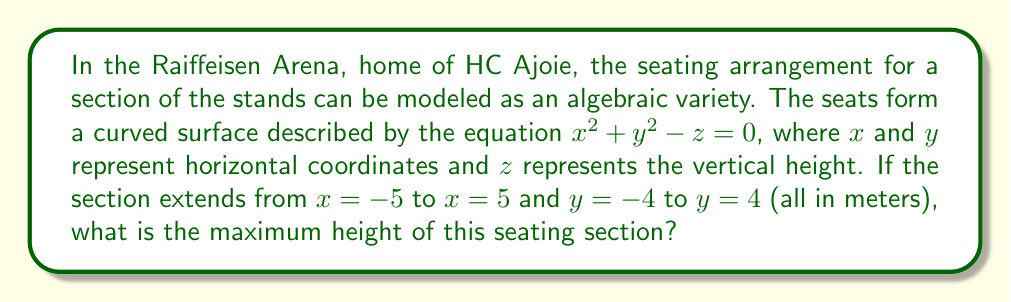Provide a solution to this math problem. Let's approach this step-by-step:

1) The seating arrangement is modeled by the equation $x^2 + y^2 - z = 0$.

2) We need to rearrange this equation to express $z$ in terms of $x$ and $y$:
   $z = x^2 + y^2$

3) The maximum height (z) will occur at the point where $x^2 + y^2$ is largest within the given bounds.

4) The section extends from $x = -5$ to $x = 5$ and $y = -4$ to $y = 4$.

5) The largest possible values for $x^2$ and $y^2$ will be at the corners of this rectangular region:
   $x = \pm 5$ and $y = \pm 4$

6) At these corners:
   $z = x^2 + y^2 = (\pm 5)^2 + (\pm 4)^2 = 25 + 16 = 41$

7) Therefore, the maximum height of the seating section is 41 meters.
Answer: 41 meters 